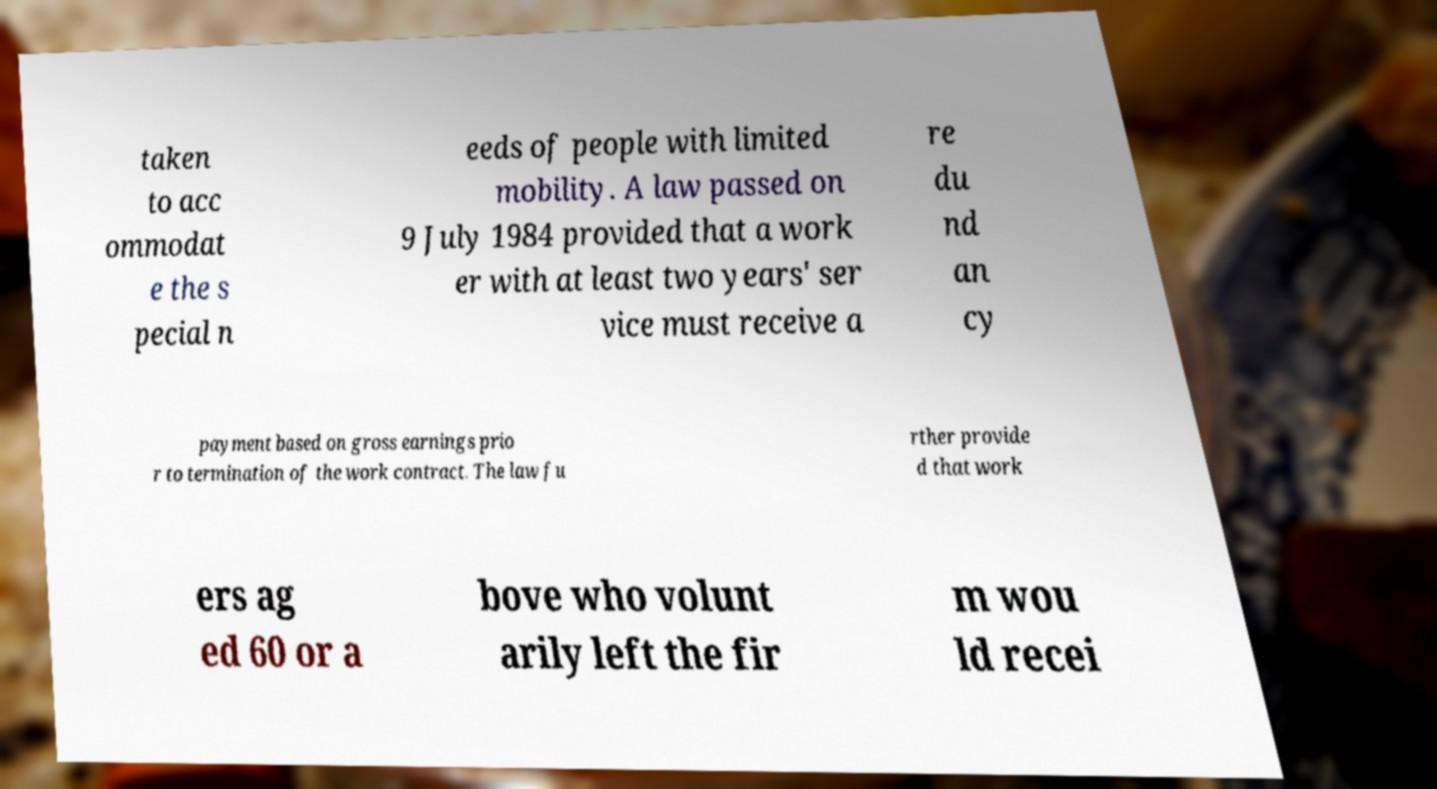Please read and relay the text visible in this image. What does it say? taken to acc ommodat e the s pecial n eeds of people with limited mobility. A law passed on 9 July 1984 provided that a work er with at least two years' ser vice must receive a re du nd an cy payment based on gross earnings prio r to termination of the work contract. The law fu rther provide d that work ers ag ed 60 or a bove who volunt arily left the fir m wou ld recei 